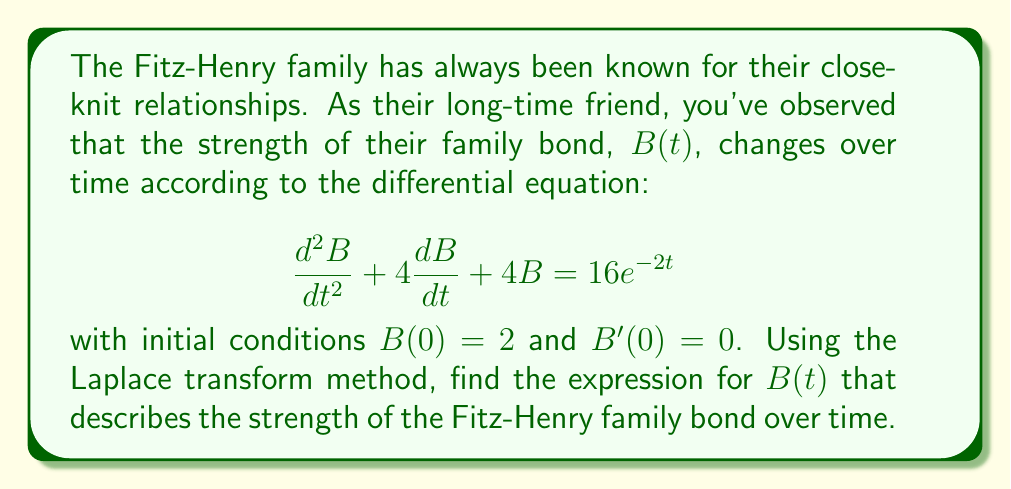Solve this math problem. Let's solve this using the Laplace transform method:

1) Take the Laplace transform of both sides of the equation:
   $$\mathcal{L}\{\frac{d^2B}{dt^2} + 4\frac{dB}{dt} + 4B\} = \mathcal{L}\{16e^{-2t}\}$$

2) Using Laplace transform properties:
   $$(s^2B(s) - sB(0) - B'(0)) + 4(sB(s) - B(0)) + 4B(s) = \frac{16}{s+2}$$

3) Substitute the initial conditions $B(0) = 2$ and $B'(0) = 0$:
   $$(s^2B(s) - 2s) + 4(sB(s) - 2) + 4B(s) = \frac{16}{s+2}$$

4) Simplify:
   $$s^2B(s) + 4sB(s) + 4B(s) - 2s - 8 = \frac{16}{s+2}$$
   $$(s^2 + 4s + 4)B(s) = \frac{16}{s+2} + 2s + 8$$

5) Factor the left side:
   $$(s+2)^2B(s) = \frac{16}{s+2} + 2s + 8$$

6) Multiply both sides by $(s+2)$:
   $$(s+2)^3B(s) = 16 + 2s(s+2) + 8(s+2)$$
   $$(s+2)^3B(s) = 2s^2 + 12s + 24$$

7) Divide both sides by $(s+2)^3$:
   $$B(s) = \frac{2s^2 + 12s + 24}{(s+2)^3}$$

8) Use partial fraction decomposition:
   $$B(s) = \frac{A}{s+2} + \frac{B}{(s+2)^2} + \frac{C}{(s+2)^3}$$

   Solving for $A$, $B$, and $C$, we get:
   $$B(s) = 2 + \frac{2}{s+2} + \frac{2}{(s+2)^2}$$

9) Take the inverse Laplace transform:
   $$B(t) = \mathcal{L}^{-1}\{2\} + \mathcal{L}^{-1}\{\frac{2}{s+2}\} + \mathcal{L}^{-1}\{\frac{2}{(s+2)^2}\}$$
   $$B(t) = 2 + 2e^{-2t} + 2te^{-2t}$$
Answer: $B(t) = 2 + 2e^{-2t} + 2te^{-2t}$ 